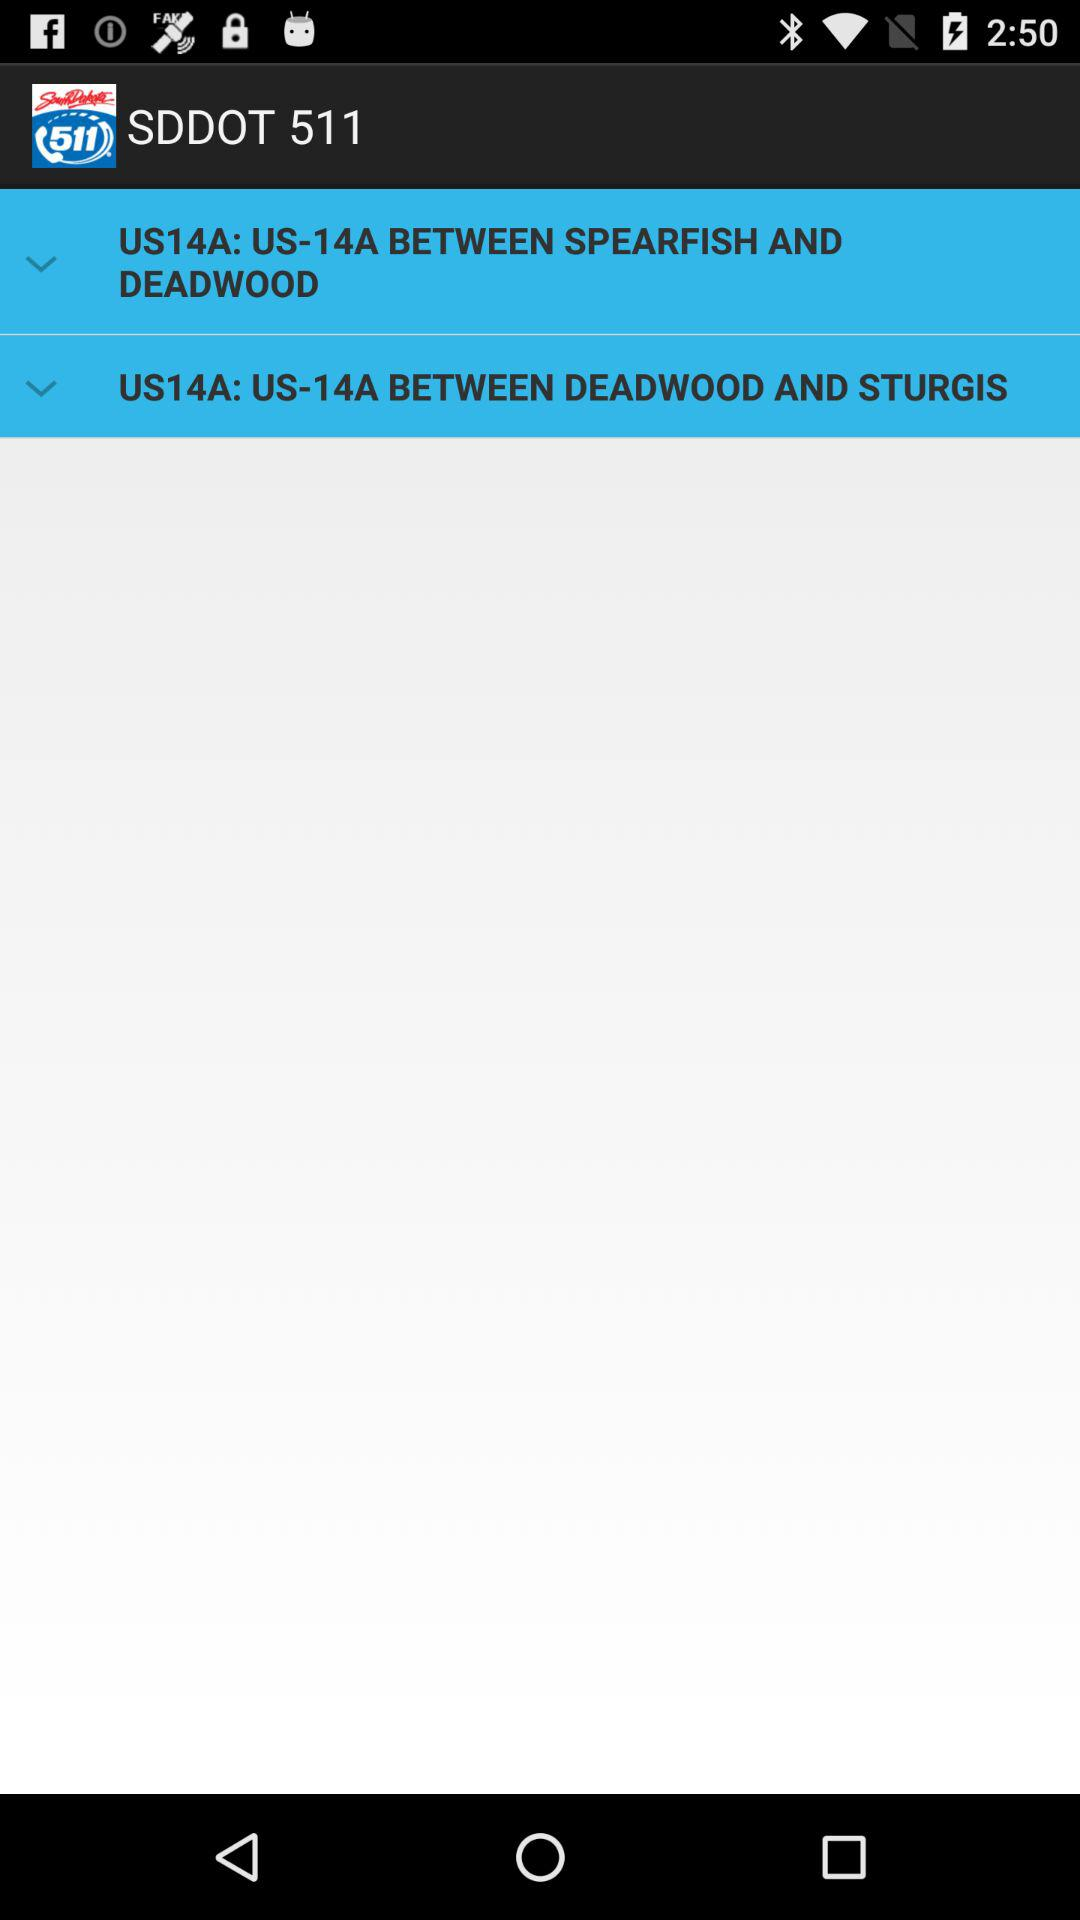What is the name of the application? The name of the application is "SDDOT 511". 